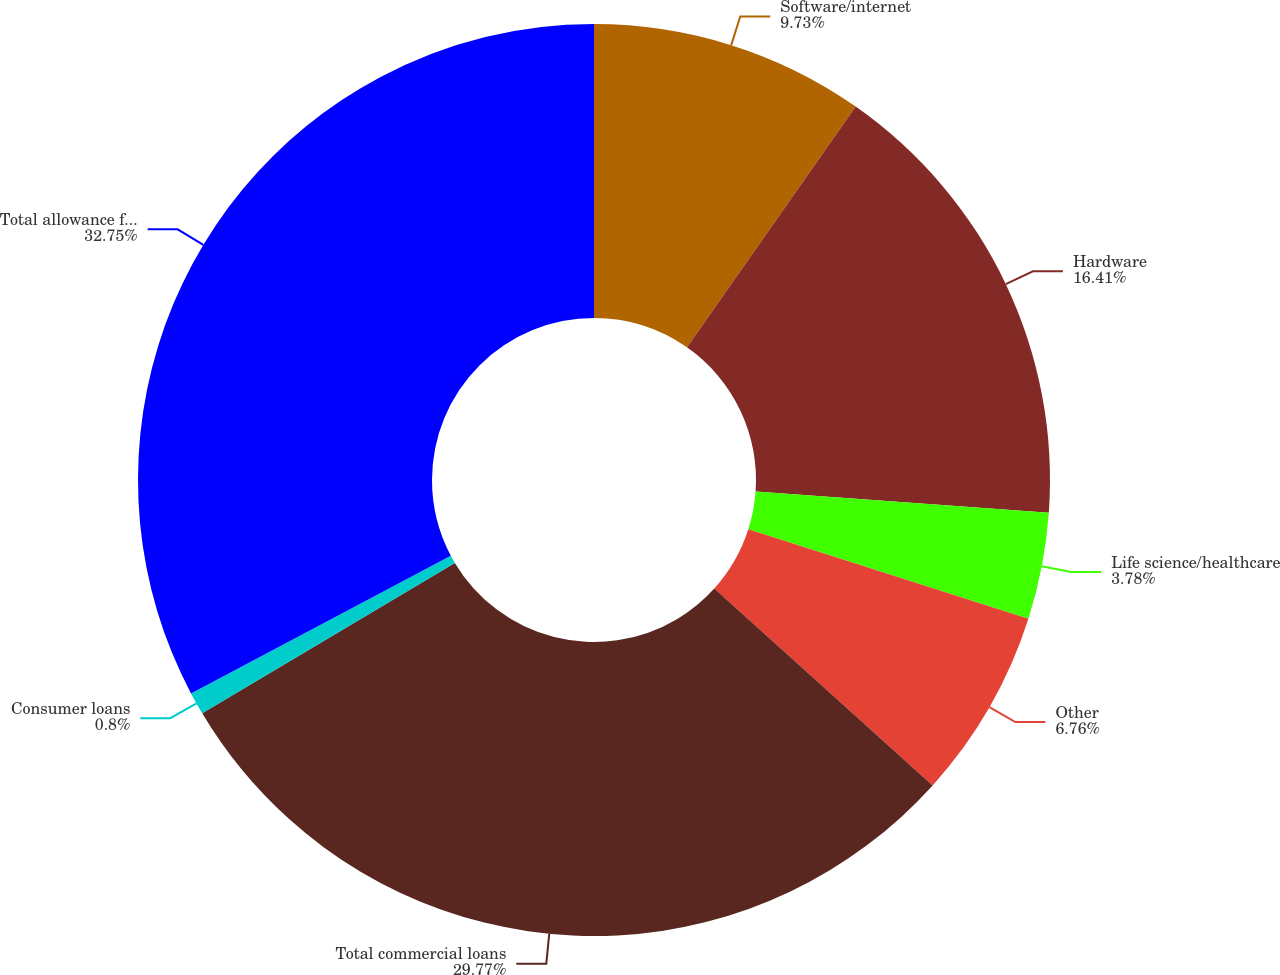Convert chart to OTSL. <chart><loc_0><loc_0><loc_500><loc_500><pie_chart><fcel>Software/internet<fcel>Hardware<fcel>Life science/healthcare<fcel>Other<fcel>Total commercial loans<fcel>Consumer loans<fcel>Total allowance for loan<nl><fcel>9.73%<fcel>16.41%<fcel>3.78%<fcel>6.76%<fcel>29.77%<fcel>0.8%<fcel>32.75%<nl></chart> 